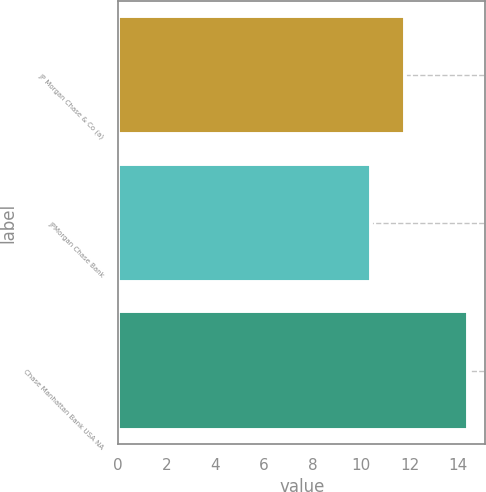Convert chart to OTSL. <chart><loc_0><loc_0><loc_500><loc_500><bar_chart><fcel>JP Morgan Chase & Co (a)<fcel>JPMorgan Chase Bank<fcel>Chase Manhattan Bank USA NA<nl><fcel>11.8<fcel>10.4<fcel>14.4<nl></chart> 